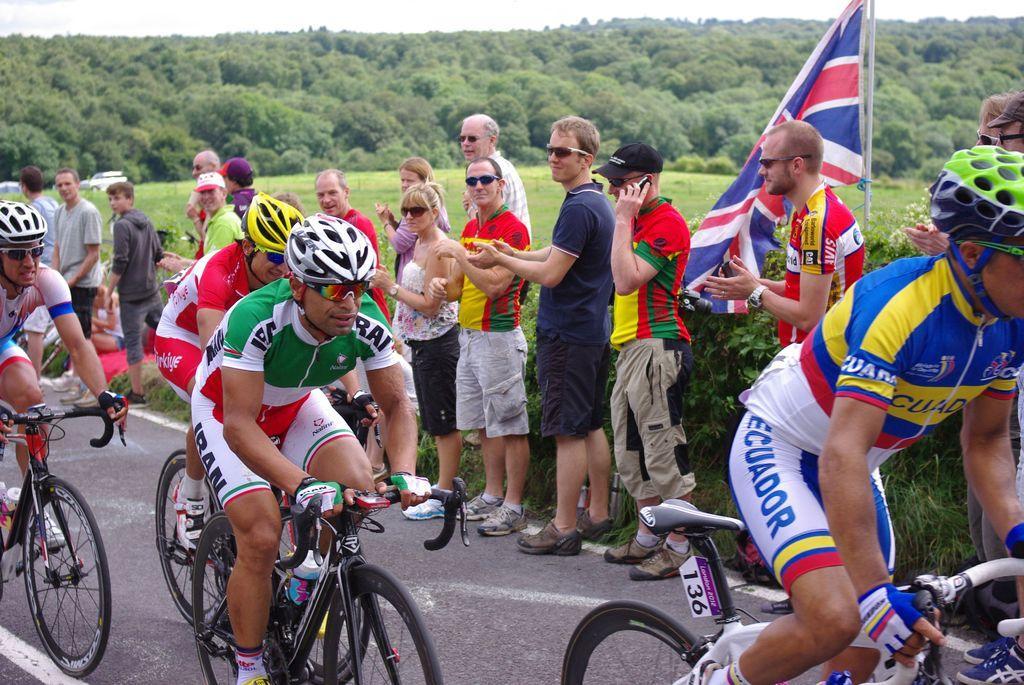In one or two sentences, can you explain what this image depicts? Bottom of the image few people are riding bicycles. Behind them few people are standing and watching. Top right side of the image there is a flag. Top left side of the image there are some trees and there is a sky and clouds. Left side of the image there are two vehicles. 